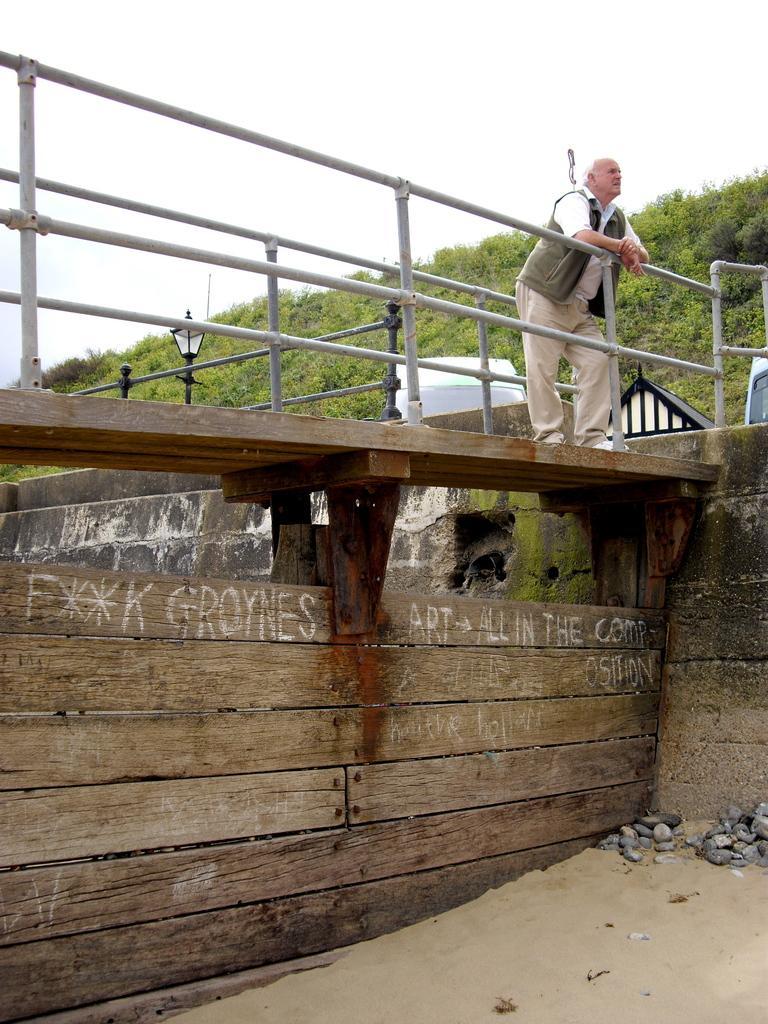How would you summarize this image in a sentence or two? In this image we can see a person standing on the bridge, few stones on the ground, there are few railings, a light pole, objects looks like vehicles and tent and there are few trees and the sky in the background. 